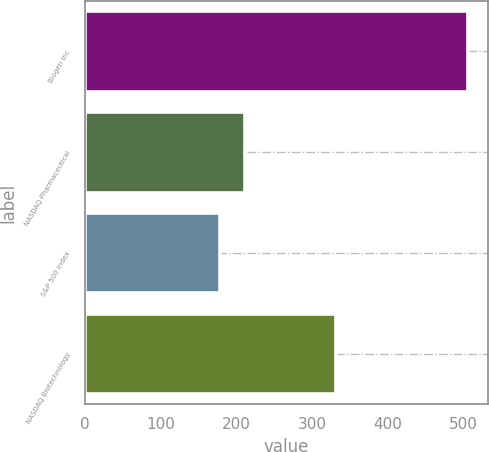Convert chart. <chart><loc_0><loc_0><loc_500><loc_500><bar_chart><fcel>Biogen Inc<fcel>NASDAQ Pharmaceutical<fcel>S&P 500 Index<fcel>NASDAQ Biotechnology<nl><fcel>506.26<fcel>211.08<fcel>178.28<fcel>331.99<nl></chart> 